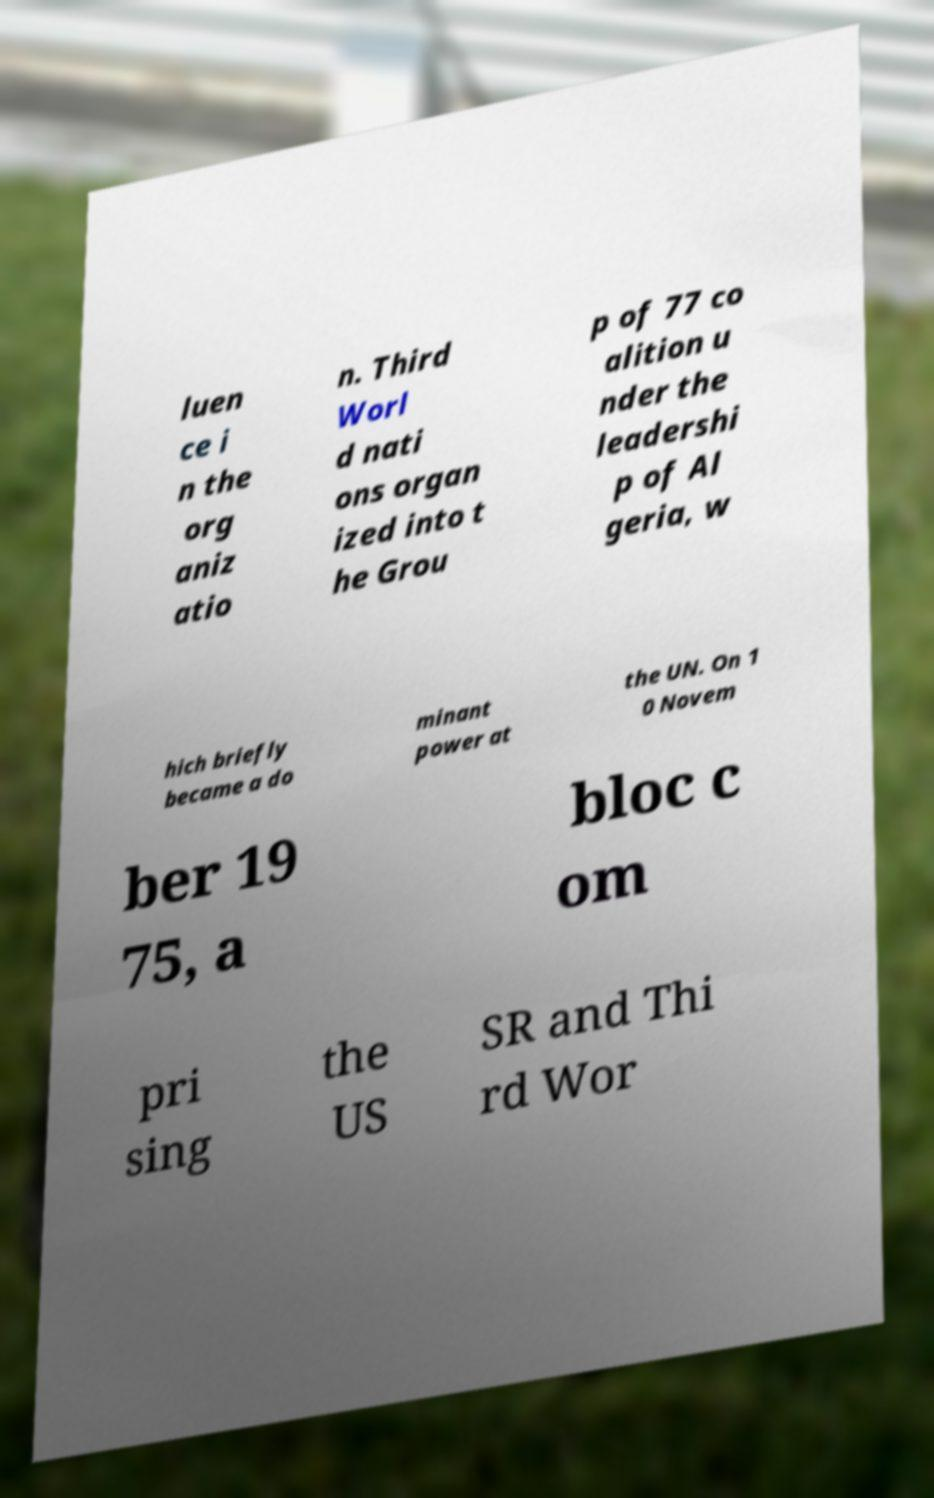Please read and relay the text visible in this image. What does it say? luen ce i n the org aniz atio n. Third Worl d nati ons organ ized into t he Grou p of 77 co alition u nder the leadershi p of Al geria, w hich briefly became a do minant power at the UN. On 1 0 Novem ber 19 75, a bloc c om pri sing the US SR and Thi rd Wor 